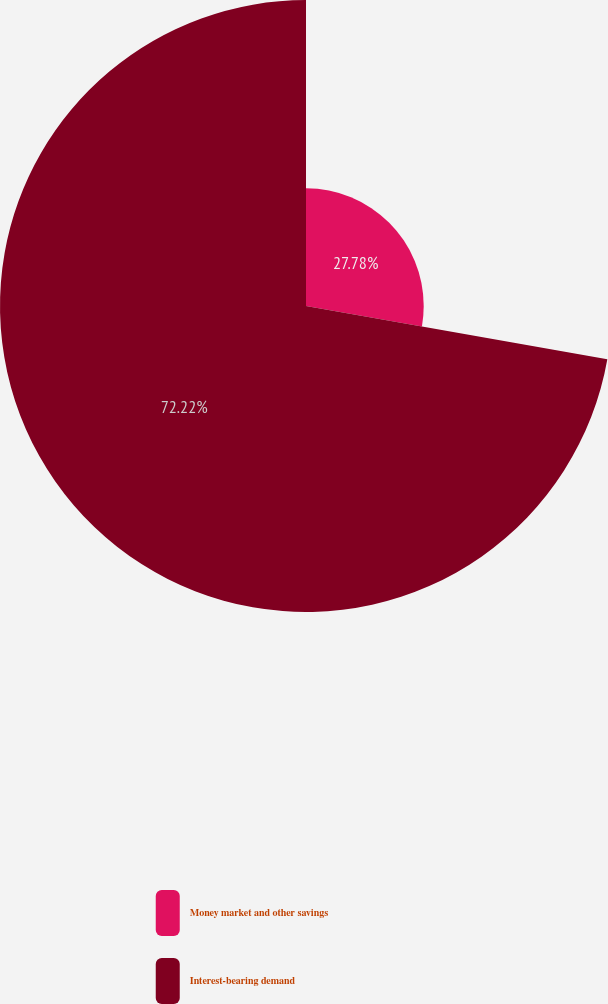<chart> <loc_0><loc_0><loc_500><loc_500><pie_chart><fcel>Money market and other savings<fcel>Interest-bearing demand<nl><fcel>27.78%<fcel>72.22%<nl></chart> 